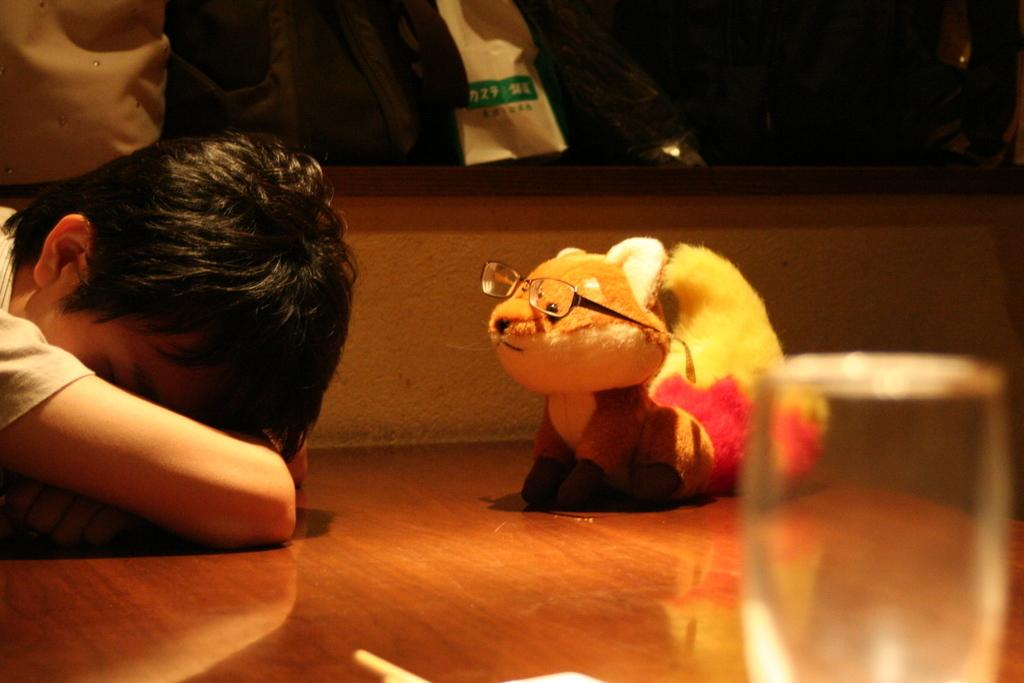What is the main subject of the image? There is a person in the image. What object can be seen near the person? There is a glass in the image. What other item is visible in the image? There is a toy in the image. What accessory is the person wearing? The person is wearing spectacles. What type of jelly can be seen on the person's face in the image? There is no jelly present on the person's face in the image. What is the person writing in the image? The image does not show the person writing anything. 